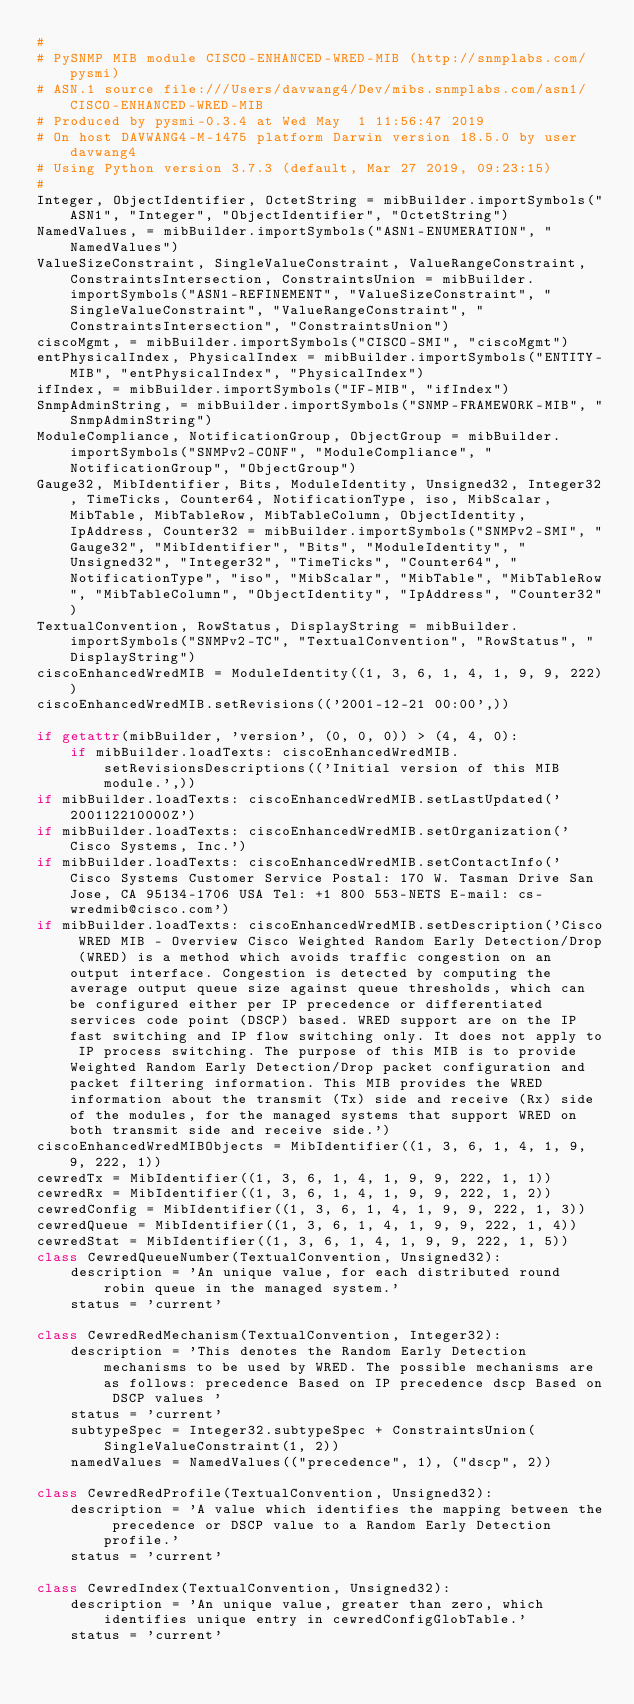Convert code to text. <code><loc_0><loc_0><loc_500><loc_500><_Python_>#
# PySNMP MIB module CISCO-ENHANCED-WRED-MIB (http://snmplabs.com/pysmi)
# ASN.1 source file:///Users/davwang4/Dev/mibs.snmplabs.com/asn1/CISCO-ENHANCED-WRED-MIB
# Produced by pysmi-0.3.4 at Wed May  1 11:56:47 2019
# On host DAVWANG4-M-1475 platform Darwin version 18.5.0 by user davwang4
# Using Python version 3.7.3 (default, Mar 27 2019, 09:23:15) 
#
Integer, ObjectIdentifier, OctetString = mibBuilder.importSymbols("ASN1", "Integer", "ObjectIdentifier", "OctetString")
NamedValues, = mibBuilder.importSymbols("ASN1-ENUMERATION", "NamedValues")
ValueSizeConstraint, SingleValueConstraint, ValueRangeConstraint, ConstraintsIntersection, ConstraintsUnion = mibBuilder.importSymbols("ASN1-REFINEMENT", "ValueSizeConstraint", "SingleValueConstraint", "ValueRangeConstraint", "ConstraintsIntersection", "ConstraintsUnion")
ciscoMgmt, = mibBuilder.importSymbols("CISCO-SMI", "ciscoMgmt")
entPhysicalIndex, PhysicalIndex = mibBuilder.importSymbols("ENTITY-MIB", "entPhysicalIndex", "PhysicalIndex")
ifIndex, = mibBuilder.importSymbols("IF-MIB", "ifIndex")
SnmpAdminString, = mibBuilder.importSymbols("SNMP-FRAMEWORK-MIB", "SnmpAdminString")
ModuleCompliance, NotificationGroup, ObjectGroup = mibBuilder.importSymbols("SNMPv2-CONF", "ModuleCompliance", "NotificationGroup", "ObjectGroup")
Gauge32, MibIdentifier, Bits, ModuleIdentity, Unsigned32, Integer32, TimeTicks, Counter64, NotificationType, iso, MibScalar, MibTable, MibTableRow, MibTableColumn, ObjectIdentity, IpAddress, Counter32 = mibBuilder.importSymbols("SNMPv2-SMI", "Gauge32", "MibIdentifier", "Bits", "ModuleIdentity", "Unsigned32", "Integer32", "TimeTicks", "Counter64", "NotificationType", "iso", "MibScalar", "MibTable", "MibTableRow", "MibTableColumn", "ObjectIdentity", "IpAddress", "Counter32")
TextualConvention, RowStatus, DisplayString = mibBuilder.importSymbols("SNMPv2-TC", "TextualConvention", "RowStatus", "DisplayString")
ciscoEnhancedWredMIB = ModuleIdentity((1, 3, 6, 1, 4, 1, 9, 9, 222))
ciscoEnhancedWredMIB.setRevisions(('2001-12-21 00:00',))

if getattr(mibBuilder, 'version', (0, 0, 0)) > (4, 4, 0):
    if mibBuilder.loadTexts: ciscoEnhancedWredMIB.setRevisionsDescriptions(('Initial version of this MIB module.',))
if mibBuilder.loadTexts: ciscoEnhancedWredMIB.setLastUpdated('200112210000Z')
if mibBuilder.loadTexts: ciscoEnhancedWredMIB.setOrganization('Cisco Systems, Inc.')
if mibBuilder.loadTexts: ciscoEnhancedWredMIB.setContactInfo(' Cisco Systems Customer Service Postal: 170 W. Tasman Drive San Jose, CA 95134-1706 USA Tel: +1 800 553-NETS E-mail: cs-wredmib@cisco.com')
if mibBuilder.loadTexts: ciscoEnhancedWredMIB.setDescription('Cisco WRED MIB - Overview Cisco Weighted Random Early Detection/Drop (WRED) is a method which avoids traffic congestion on an output interface. Congestion is detected by computing the average output queue size against queue thresholds, which can be configured either per IP precedence or differentiated services code point (DSCP) based. WRED support are on the IP fast switching and IP flow switching only. It does not apply to IP process switching. The purpose of this MIB is to provide Weighted Random Early Detection/Drop packet configuration and packet filtering information. This MIB provides the WRED information about the transmit (Tx) side and receive (Rx) side of the modules, for the managed systems that support WRED on both transmit side and receive side.')
ciscoEnhancedWredMIBObjects = MibIdentifier((1, 3, 6, 1, 4, 1, 9, 9, 222, 1))
cewredTx = MibIdentifier((1, 3, 6, 1, 4, 1, 9, 9, 222, 1, 1))
cewredRx = MibIdentifier((1, 3, 6, 1, 4, 1, 9, 9, 222, 1, 2))
cewredConfig = MibIdentifier((1, 3, 6, 1, 4, 1, 9, 9, 222, 1, 3))
cewredQueue = MibIdentifier((1, 3, 6, 1, 4, 1, 9, 9, 222, 1, 4))
cewredStat = MibIdentifier((1, 3, 6, 1, 4, 1, 9, 9, 222, 1, 5))
class CewredQueueNumber(TextualConvention, Unsigned32):
    description = 'An unique value, for each distributed round robin queue in the managed system.'
    status = 'current'

class CewredRedMechanism(TextualConvention, Integer32):
    description = 'This denotes the Random Early Detection mechanisms to be used by WRED. The possible mechanisms are as follows: precedence Based on IP precedence dscp Based on DSCP values '
    status = 'current'
    subtypeSpec = Integer32.subtypeSpec + ConstraintsUnion(SingleValueConstraint(1, 2))
    namedValues = NamedValues(("precedence", 1), ("dscp", 2))

class CewredRedProfile(TextualConvention, Unsigned32):
    description = 'A value which identifies the mapping between the precedence or DSCP value to a Random Early Detection profile.'
    status = 'current'

class CewredIndex(TextualConvention, Unsigned32):
    description = 'An unique value, greater than zero, which identifies unique entry in cewredConfigGlobTable.'
    status = 'current'</code> 